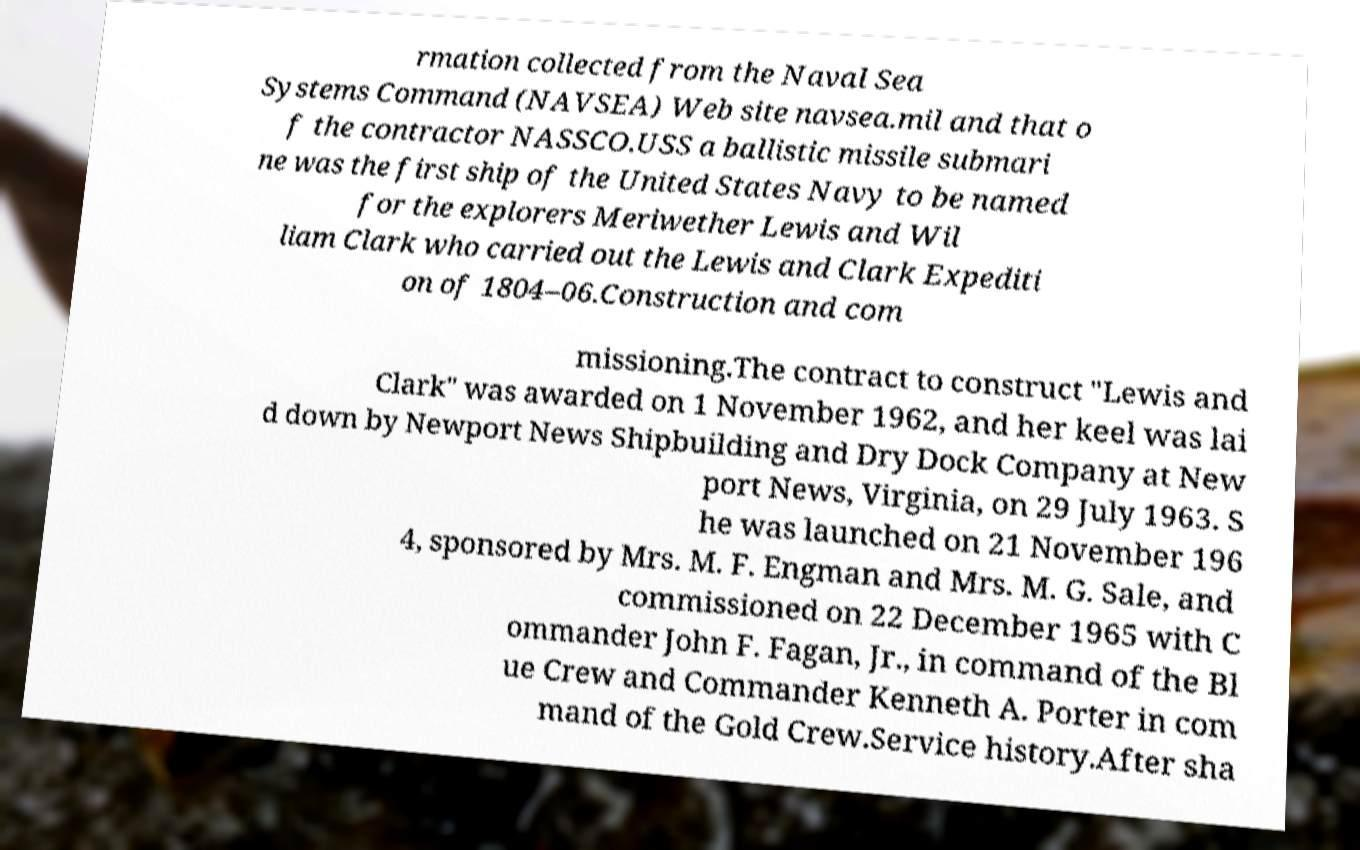What messages or text are displayed in this image? I need them in a readable, typed format. rmation collected from the Naval Sea Systems Command (NAVSEA) Web site navsea.mil and that o f the contractor NASSCO.USS a ballistic missile submari ne was the first ship of the United States Navy to be named for the explorers Meriwether Lewis and Wil liam Clark who carried out the Lewis and Clark Expediti on of 1804–06.Construction and com missioning.The contract to construct "Lewis and Clark" was awarded on 1 November 1962, and her keel was lai d down by Newport News Shipbuilding and Dry Dock Company at New port News, Virginia, on 29 July 1963. S he was launched on 21 November 196 4, sponsored by Mrs. M. F. Engman and Mrs. M. G. Sale, and commissioned on 22 December 1965 with C ommander John F. Fagan, Jr., in command of the Bl ue Crew and Commander Kenneth A. Porter in com mand of the Gold Crew.Service history.After sha 